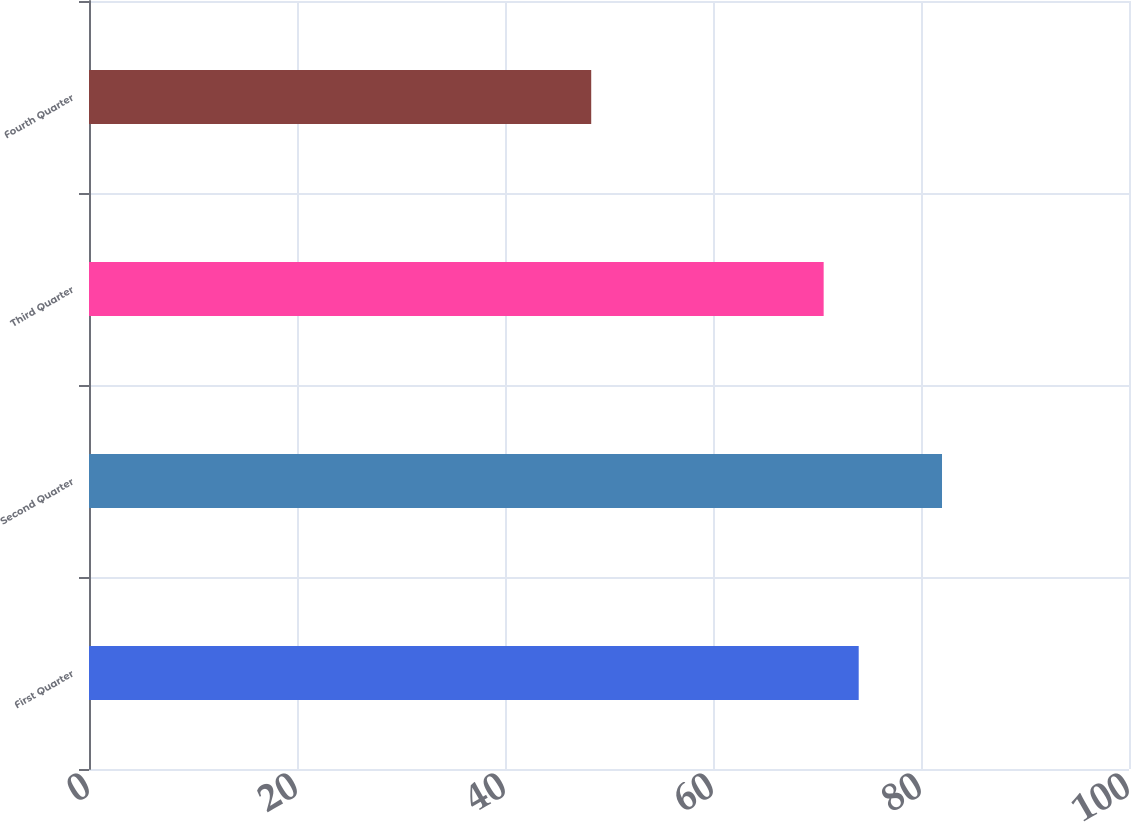<chart> <loc_0><loc_0><loc_500><loc_500><bar_chart><fcel>First Quarter<fcel>Second Quarter<fcel>Third Quarter<fcel>Fourth Quarter<nl><fcel>74.01<fcel>82.02<fcel>70.64<fcel>48.29<nl></chart> 